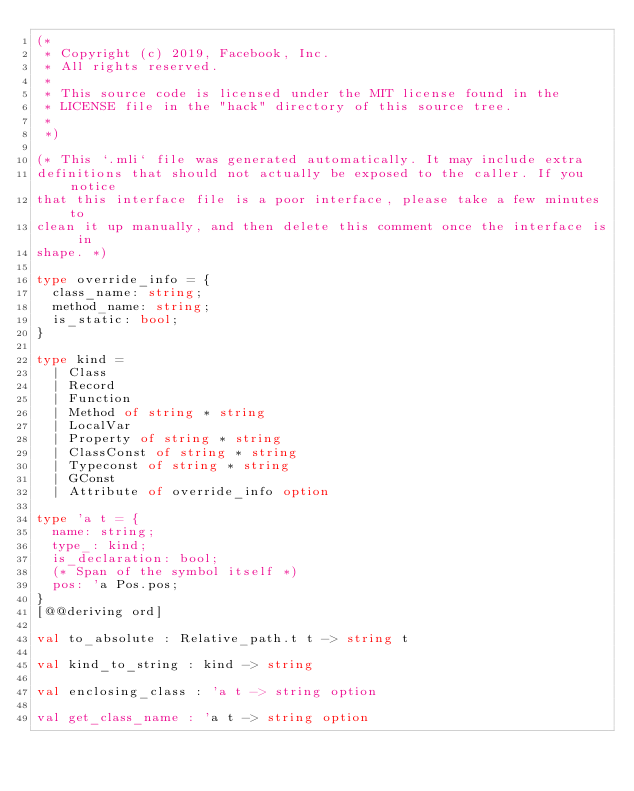<code> <loc_0><loc_0><loc_500><loc_500><_OCaml_>(*
 * Copyright (c) 2019, Facebook, Inc.
 * All rights reserved.
 *
 * This source code is licensed under the MIT license found in the
 * LICENSE file in the "hack" directory of this source tree.
 *
 *)

(* This `.mli` file was generated automatically. It may include extra
definitions that should not actually be exposed to the caller. If you notice
that this interface file is a poor interface, please take a few minutes to
clean it up manually, and then delete this comment once the interface is in
shape. *)

type override_info = {
  class_name: string;
  method_name: string;
  is_static: bool;
}

type kind =
  | Class
  | Record
  | Function
  | Method of string * string
  | LocalVar
  | Property of string * string
  | ClassConst of string * string
  | Typeconst of string * string
  | GConst
  | Attribute of override_info option

type 'a t = {
  name: string;
  type_: kind;
  is_declaration: bool;
  (* Span of the symbol itself *)
  pos: 'a Pos.pos;
}
[@@deriving ord]

val to_absolute : Relative_path.t t -> string t

val kind_to_string : kind -> string

val enclosing_class : 'a t -> string option

val get_class_name : 'a t -> string option
</code> 